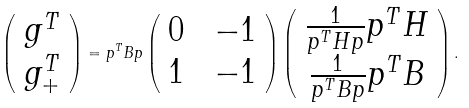Convert formula to latex. <formula><loc_0><loc_0><loc_500><loc_500>\left ( \begin{array} { c } g ^ { T } \\ g _ { + } ^ { T } \end{array} \right ) = p ^ { T } B p \left ( \begin{array} { c c } 0 & \ - 1 \\ 1 & \ - 1 \end{array} \right ) \left ( \begin{array} { c } \frac { 1 } { p ^ { T } H p } p ^ { T } H \\ \frac { 1 } { p ^ { T } B p } p ^ { T } B \end{array} \right ) .</formula> 